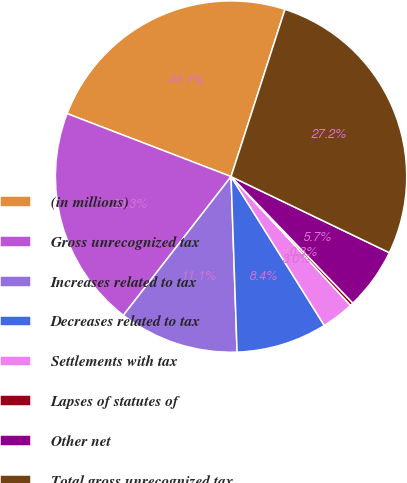Convert chart. <chart><loc_0><loc_0><loc_500><loc_500><pie_chart><fcel>(in millions)<fcel>Gross unrecognized tax<fcel>Increases related to tax<fcel>Decreases related to tax<fcel>Settlements with tax<fcel>Lapses of statutes of<fcel>Other net<fcel>Total gross unrecognized tax<nl><fcel>24.13%<fcel>20.33%<fcel>11.05%<fcel>8.36%<fcel>2.99%<fcel>0.3%<fcel>5.67%<fcel>27.17%<nl></chart> 